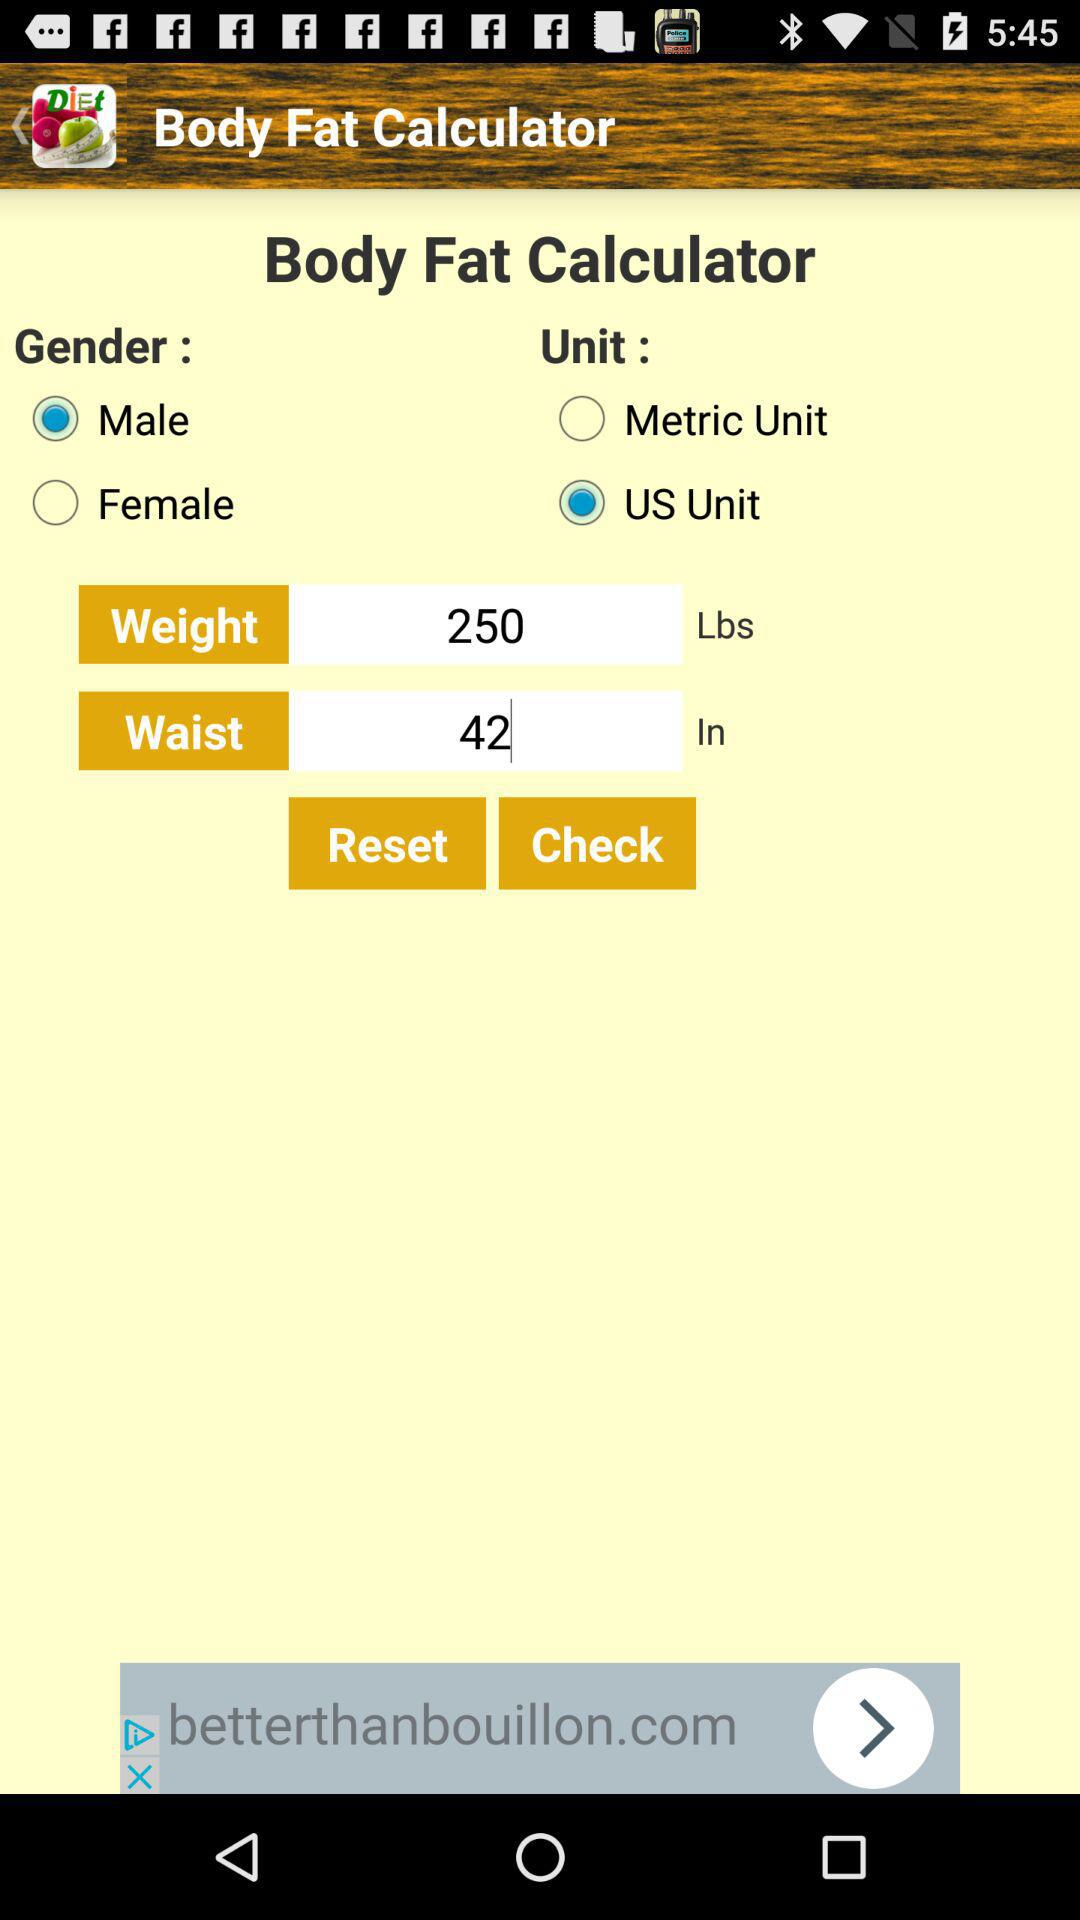What is the waist size entered? The waist size entered is 42 inches. 